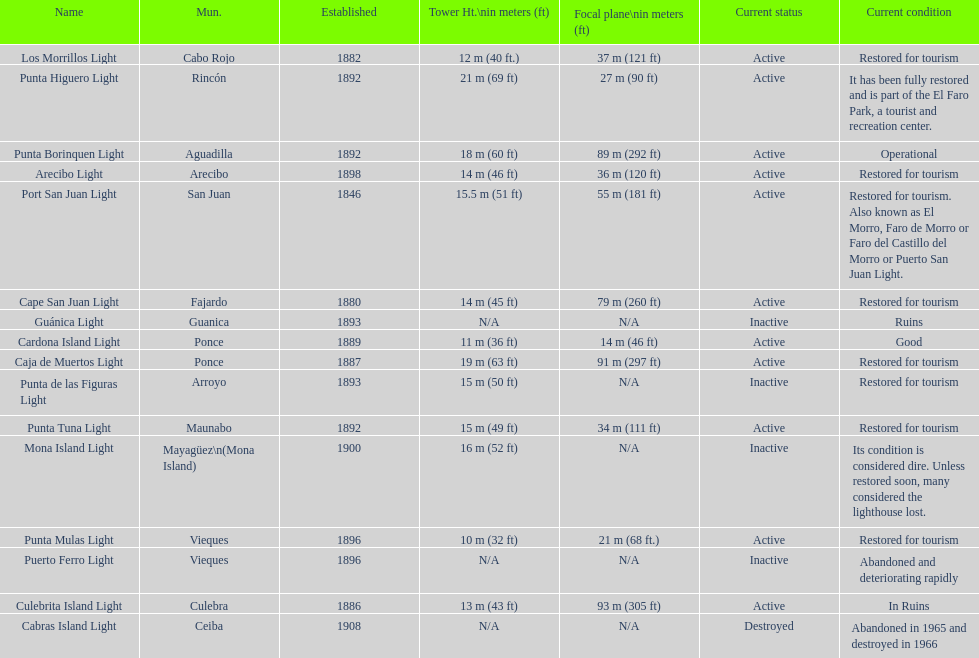Number of lighthouses that begin with the letter p 7. 